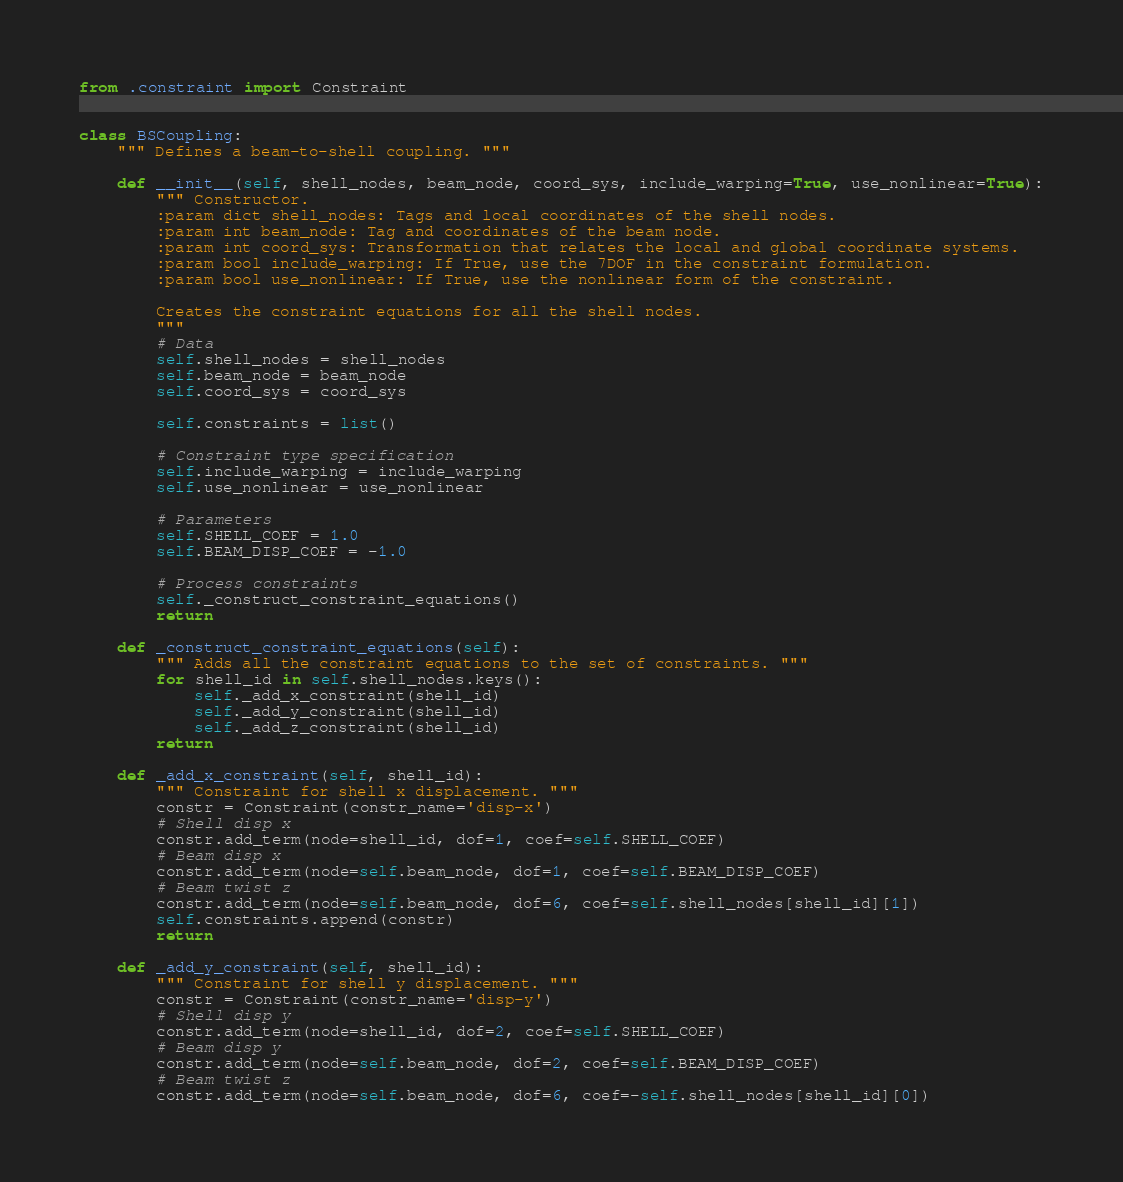<code> <loc_0><loc_0><loc_500><loc_500><_Python_>from .constraint import Constraint


class BSCoupling:
    """ Defines a beam-to-shell coupling. """

    def __init__(self, shell_nodes, beam_node, coord_sys, include_warping=True, use_nonlinear=True):
        """ Constructor.
        :param dict shell_nodes: Tags and local coordinates of the shell nodes.
        :param int beam_node: Tag and coordinates of the beam node.
        :param int coord_sys: Transformation that relates the local and global coordinate systems.
        :param bool include_warping: If True, use the 7DOF in the constraint formulation.
        :param bool use_nonlinear: If True, use the nonlinear form of the constraint.

        Creates the constraint equations for all the shell nodes.
        """
        # Data
        self.shell_nodes = shell_nodes
        self.beam_node = beam_node
        self.coord_sys = coord_sys

        self.constraints = list()

        # Constraint type specification
        self.include_warping = include_warping
        self.use_nonlinear = use_nonlinear

        # Parameters
        self.SHELL_COEF = 1.0
        self.BEAM_DISP_COEF = -1.0

        # Process constraints
        self._construct_constraint_equations()
        return

    def _construct_constraint_equations(self):
        """ Adds all the constraint equations to the set of constraints. """
        for shell_id in self.shell_nodes.keys():
            self._add_x_constraint(shell_id)
            self._add_y_constraint(shell_id)
            self._add_z_constraint(shell_id)
        return

    def _add_x_constraint(self, shell_id):
        """ Constraint for shell x displacement. """
        constr = Constraint(constr_name='disp-x')
        # Shell disp x
        constr.add_term(node=shell_id, dof=1, coef=self.SHELL_COEF)
        # Beam disp x
        constr.add_term(node=self.beam_node, dof=1, coef=self.BEAM_DISP_COEF)
        # Beam twist z
        constr.add_term(node=self.beam_node, dof=6, coef=self.shell_nodes[shell_id][1])
        self.constraints.append(constr)
        return

    def _add_y_constraint(self, shell_id):
        """ Constraint for shell y displacement. """
        constr = Constraint(constr_name='disp-y')
        # Shell disp y
        constr.add_term(node=shell_id, dof=2, coef=self.SHELL_COEF)
        # Beam disp y
        constr.add_term(node=self.beam_node, dof=2, coef=self.BEAM_DISP_COEF)
        # Beam twist z
        constr.add_term(node=self.beam_node, dof=6, coef=-self.shell_nodes[shell_id][0])</code> 